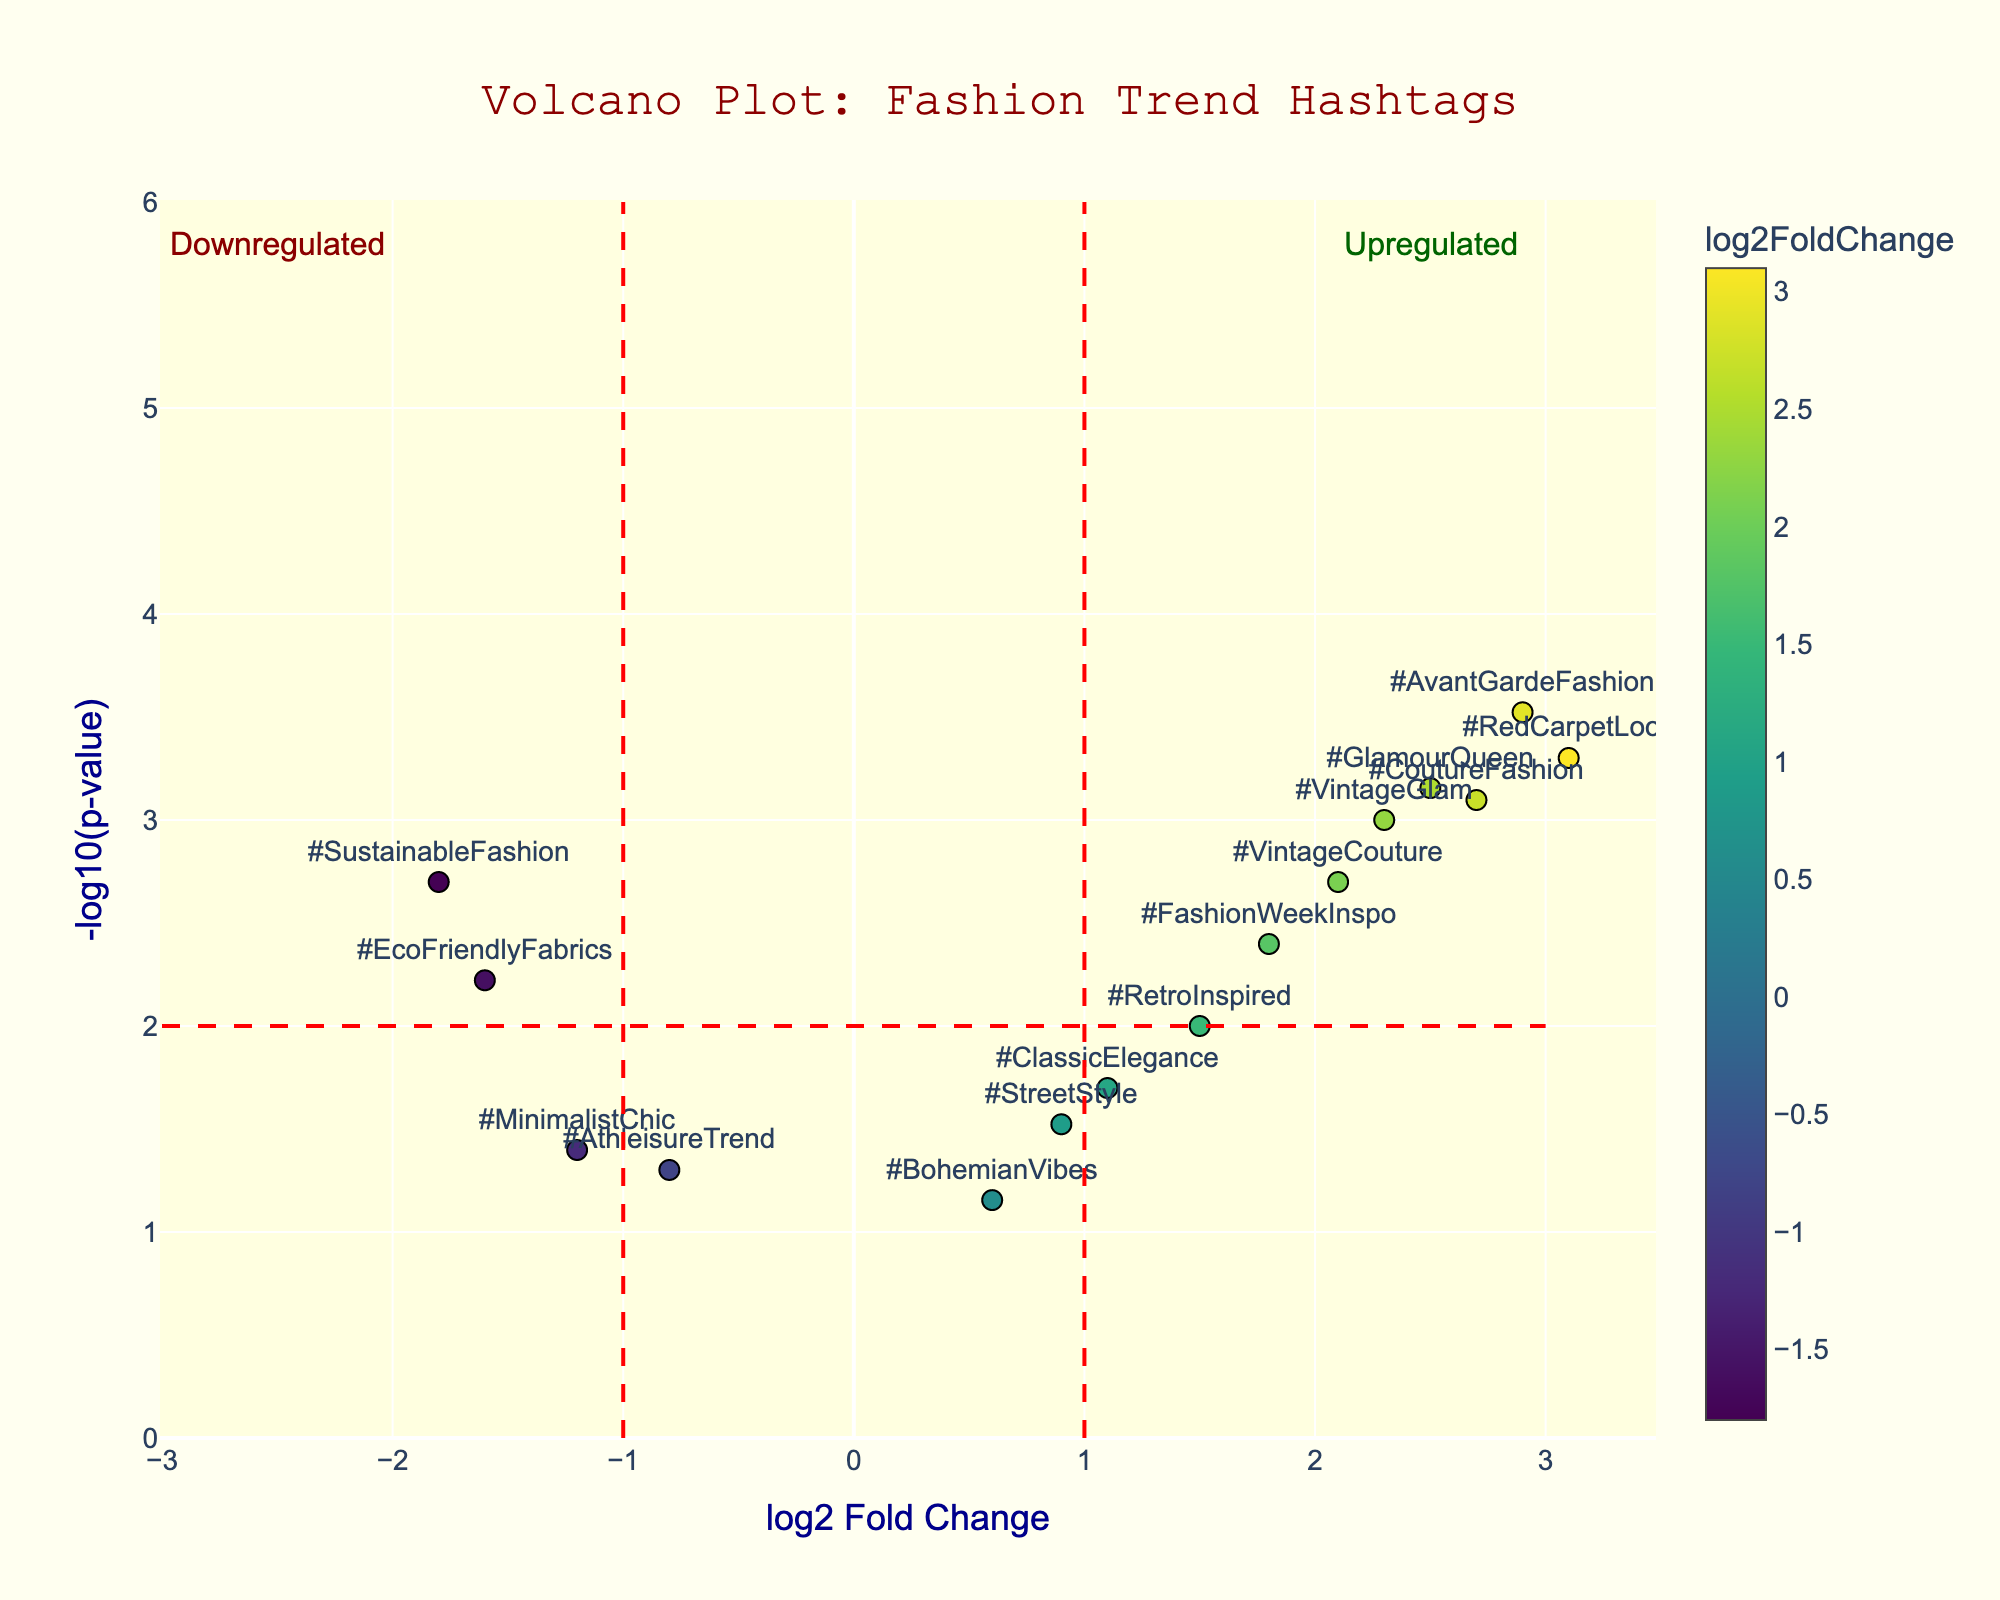What's the title of this plot? The plot's title is displayed at the top center of the figure in a unique font style that sets the context for what the figure is about.
Answer: Volcano Plot: Fashion Trend Hashtags What does the x-axis represent? The label for the x-axis is provided below the axis line, which mentions "log2 Fold Change," indicating it represents the magnitude of change in the hashtag usage.
Answer: log2 Fold Change What does the y-axis represent? The label for the y-axis is located beside the axis line, indicating it represents the significance of the hashtags by displaying "-log10(p-value)."
Answer: -log10(p-value) Based on the plot, which hashtag has the highest log2 fold change? By examining the data points and their annotations, the hashtag at the far right of the plot with the greatest x-axis value represents the highest log2 fold change.
Answer: #RedCarpetLook Which hashtag shows the highest statistical significance? The highest statistical significance corresponds to the point with the highest y-value, as -log10(p-value) is plotted on the y-axis.
Answer: #AvantGardeFashion How many hashtags are considered upregulated (log2 fold change > 1 and -log10(p-value) > 2)? By identifying the data points located in the top right quadrant of the plot (where log2 fold change > 1 and -log10(p-value) > 2), we can count the number of hashtags that are upregulated.
Answer: 8 Which hashtag appears to have a significant downregulation? By examining the left side of the plot and identifying hashtags with negative log2 fold change and high -log10(p-value), the most significant one is the one with the highest y-value in this quadrant.
Answer: #SustainableFashion Compare the significance of #ClassicElegance and #AthleisureTrend. Which one is more statistically significant? By comparing the y-values of both hashtags, the one with the higher y-value (which means lower p-value, thus more significant) is the more statistically significant one.
Answer: #ClassicElegance Identify the hashtag that is on the borderline of being considered significant. The threshold lines indicate the cutoffs. The hashtag closest to the threshold lines is considered borderline for significance.
Answer: #MinimalistChic What does the color of the data points represent? The color scale and the color bar on the plot indicate that data points are colored based on their log2 fold change values, with lighter and darker shades representing different extents of change.
Answer: log2 Fold Change 